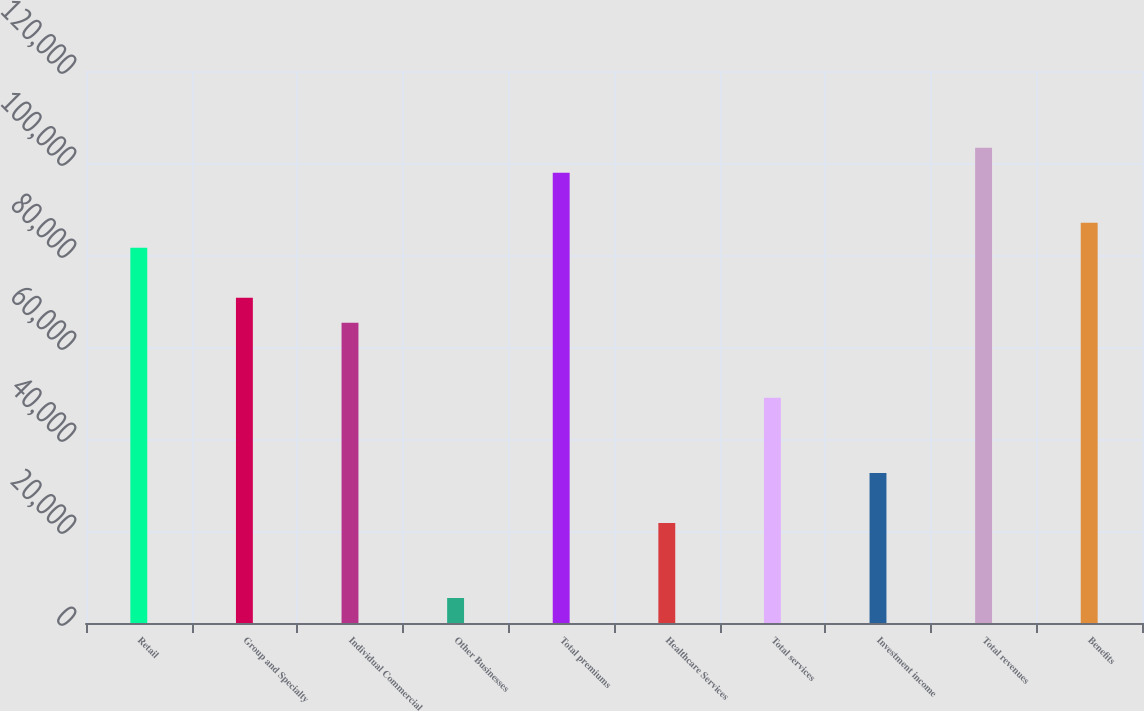Convert chart to OTSL. <chart><loc_0><loc_0><loc_500><loc_500><bar_chart><fcel>Retail<fcel>Group and Specialty<fcel>Individual Commercial<fcel>Other Businesses<fcel>Total premiums<fcel>Healthcare Services<fcel>Total services<fcel>Investment income<fcel>Total revenues<fcel>Benefits<nl><fcel>81566.4<fcel>70691.4<fcel>65253.9<fcel>5441.56<fcel>97878.9<fcel>21754<fcel>48941.5<fcel>32629<fcel>103316<fcel>87003.9<nl></chart> 